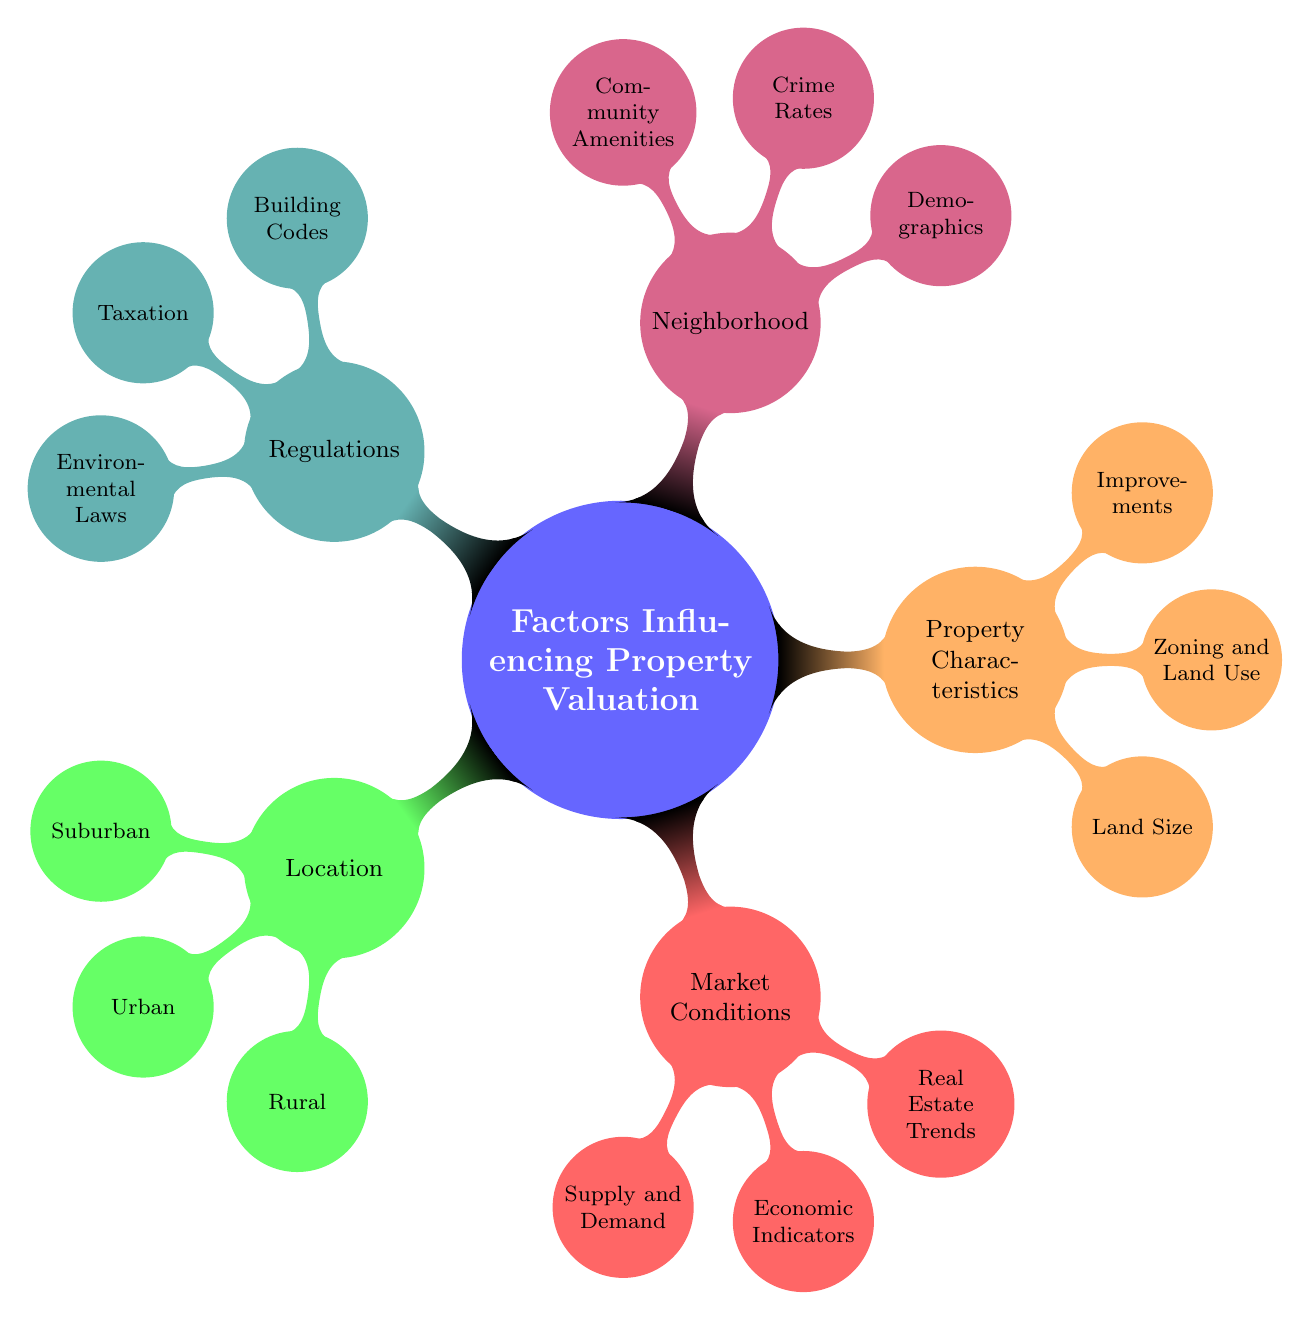What are the main categories influencing property valuation? The diagram has five main categories: Location, Market Conditions, Property Characteristics, Neighborhood, and Regulations.
Answer: Location, Market Conditions, Property Characteristics, Neighborhood, Regulations How many types of location are mentioned in the diagram? Under the Location category, there are three types: Suburban, Urban, and Rural.
Answer: Three What is one factor under Market Conditions? The Market Conditions category includes factors such as Supply and Demand, Economic Indicators, and Real Estate Trends. One example is Supply and Demand.
Answer: Supply and Demand How does property zoning affect valuation? Zoning and Land Use is a subcategory under Property Characteristics that can determine whether a property is used for residential, commercial, or mixed-use, significantly influencing its valuation.
Answer: Zoning and Land Use What types of crime statistics are considered in Neighborhood analysis? The Neighborhood category includes Crime Rates, which refers to local crime statistics and trends that can affect desirability and valuation.
Answer: Crime statistics What are the three types of regulations mentioned? The Regulations category includes Building Codes, Taxation, and Environmental Laws, all of which may influence property valuation in different ways.
Answer: Building Codes, Taxation, Environmental Laws How might economic indicators influence property valuation? Economic Indicators, part of Market Conditions, include factors like interest rates, employment rates, and GDP growth that directly impact buyer behavior and market dynamics.
Answer: Interest rates, employment rates, GDP growth Which category includes demographics and local education levels? Demographics, which includes aspects like population density, income levels, and education, is part of the Neighborhood category.
Answer: Demographics What is highlighted under Community Amenities? The Community Amenities subcategory under Neighborhood focuses on access to parks, recreation centers, and cultural attractions that enhance property value.
Answer: Access to parks, recreation centers, cultural attractions 